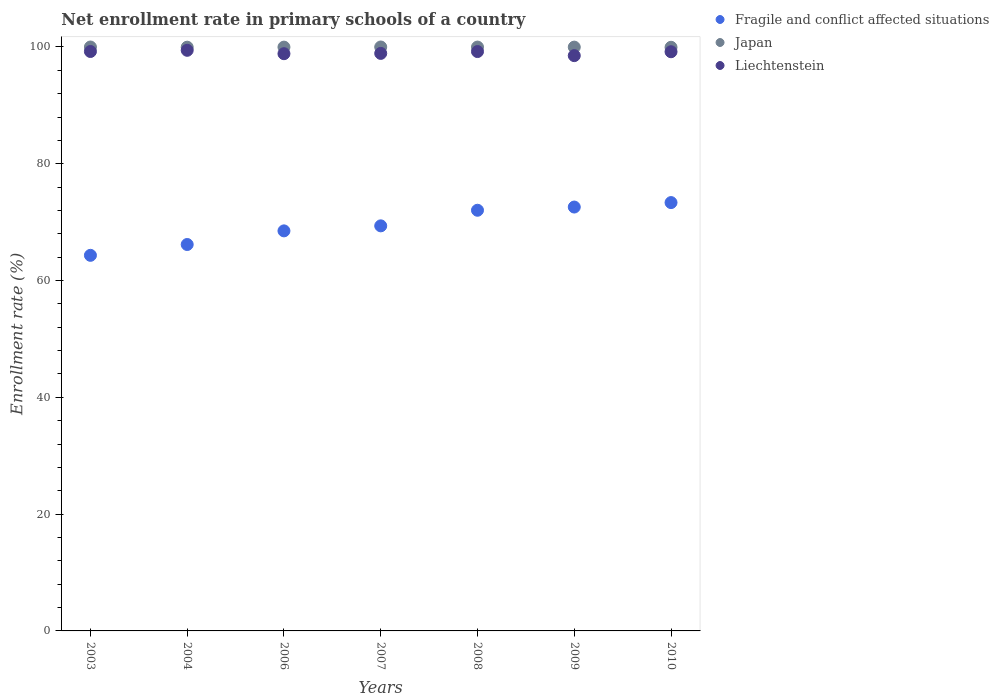How many different coloured dotlines are there?
Make the answer very short. 3. What is the enrollment rate in primary schools in Japan in 2006?
Make the answer very short. 99.98. Across all years, what is the maximum enrollment rate in primary schools in Fragile and conflict affected situations?
Make the answer very short. 73.35. Across all years, what is the minimum enrollment rate in primary schools in Japan?
Provide a short and direct response. 99.95. In which year was the enrollment rate in primary schools in Fragile and conflict affected situations maximum?
Keep it short and to the point. 2010. In which year was the enrollment rate in primary schools in Liechtenstein minimum?
Your response must be concise. 2009. What is the total enrollment rate in primary schools in Japan in the graph?
Make the answer very short. 699.85. What is the difference between the enrollment rate in primary schools in Liechtenstein in 2004 and that in 2006?
Provide a short and direct response. 0.58. What is the difference between the enrollment rate in primary schools in Fragile and conflict affected situations in 2007 and the enrollment rate in primary schools in Liechtenstein in 2008?
Your answer should be compact. -29.85. What is the average enrollment rate in primary schools in Japan per year?
Your answer should be very brief. 99.98. In the year 2003, what is the difference between the enrollment rate in primary schools in Fragile and conflict affected situations and enrollment rate in primary schools in Japan?
Offer a terse response. -35.67. What is the ratio of the enrollment rate in primary schools in Liechtenstein in 2008 to that in 2009?
Your answer should be compact. 1.01. Is the enrollment rate in primary schools in Liechtenstein in 2006 less than that in 2008?
Your answer should be compact. Yes. What is the difference between the highest and the second highest enrollment rate in primary schools in Japan?
Give a very brief answer. 0. What is the difference between the highest and the lowest enrollment rate in primary schools in Fragile and conflict affected situations?
Ensure brevity in your answer.  9.03. Is the sum of the enrollment rate in primary schools in Japan in 2008 and 2009 greater than the maximum enrollment rate in primary schools in Liechtenstein across all years?
Provide a short and direct response. Yes. Does the enrollment rate in primary schools in Liechtenstein monotonically increase over the years?
Provide a succinct answer. No. Is the enrollment rate in primary schools in Fragile and conflict affected situations strictly less than the enrollment rate in primary schools in Liechtenstein over the years?
Provide a succinct answer. Yes. How many years are there in the graph?
Give a very brief answer. 7. What is the difference between two consecutive major ticks on the Y-axis?
Your response must be concise. 20. Does the graph contain any zero values?
Give a very brief answer. No. Does the graph contain grids?
Your response must be concise. No. Where does the legend appear in the graph?
Your response must be concise. Top right. How many legend labels are there?
Make the answer very short. 3. How are the legend labels stacked?
Offer a terse response. Vertical. What is the title of the graph?
Make the answer very short. Net enrollment rate in primary schools of a country. What is the label or title of the Y-axis?
Offer a very short reply. Enrollment rate (%). What is the Enrollment rate (%) in Fragile and conflict affected situations in 2003?
Offer a terse response. 64.32. What is the Enrollment rate (%) in Japan in 2003?
Make the answer very short. 100. What is the Enrollment rate (%) in Liechtenstein in 2003?
Provide a short and direct response. 99.23. What is the Enrollment rate (%) of Fragile and conflict affected situations in 2004?
Your answer should be compact. 66.17. What is the Enrollment rate (%) in Japan in 2004?
Your answer should be compact. 99.97. What is the Enrollment rate (%) in Liechtenstein in 2004?
Your response must be concise. 99.43. What is the Enrollment rate (%) of Fragile and conflict affected situations in 2006?
Your answer should be very brief. 68.51. What is the Enrollment rate (%) in Japan in 2006?
Offer a terse response. 99.98. What is the Enrollment rate (%) in Liechtenstein in 2006?
Provide a succinct answer. 98.85. What is the Enrollment rate (%) of Fragile and conflict affected situations in 2007?
Give a very brief answer. 69.37. What is the Enrollment rate (%) of Japan in 2007?
Your response must be concise. 100. What is the Enrollment rate (%) of Liechtenstein in 2007?
Keep it short and to the point. 98.9. What is the Enrollment rate (%) in Fragile and conflict affected situations in 2008?
Keep it short and to the point. 72.04. What is the Enrollment rate (%) in Japan in 2008?
Offer a very short reply. 99.99. What is the Enrollment rate (%) in Liechtenstein in 2008?
Ensure brevity in your answer.  99.22. What is the Enrollment rate (%) of Fragile and conflict affected situations in 2009?
Make the answer very short. 72.59. What is the Enrollment rate (%) in Japan in 2009?
Your answer should be very brief. 99.98. What is the Enrollment rate (%) of Liechtenstein in 2009?
Make the answer very short. 98.52. What is the Enrollment rate (%) of Fragile and conflict affected situations in 2010?
Make the answer very short. 73.35. What is the Enrollment rate (%) of Japan in 2010?
Provide a short and direct response. 99.95. What is the Enrollment rate (%) of Liechtenstein in 2010?
Ensure brevity in your answer.  99.18. Across all years, what is the maximum Enrollment rate (%) in Fragile and conflict affected situations?
Keep it short and to the point. 73.35. Across all years, what is the maximum Enrollment rate (%) of Japan?
Your response must be concise. 100. Across all years, what is the maximum Enrollment rate (%) in Liechtenstein?
Offer a terse response. 99.43. Across all years, what is the minimum Enrollment rate (%) in Fragile and conflict affected situations?
Give a very brief answer. 64.32. Across all years, what is the minimum Enrollment rate (%) in Japan?
Make the answer very short. 99.95. Across all years, what is the minimum Enrollment rate (%) in Liechtenstein?
Keep it short and to the point. 98.52. What is the total Enrollment rate (%) of Fragile and conflict affected situations in the graph?
Offer a terse response. 486.36. What is the total Enrollment rate (%) of Japan in the graph?
Provide a short and direct response. 699.85. What is the total Enrollment rate (%) of Liechtenstein in the graph?
Your answer should be very brief. 693.34. What is the difference between the Enrollment rate (%) in Fragile and conflict affected situations in 2003 and that in 2004?
Provide a succinct answer. -1.85. What is the difference between the Enrollment rate (%) in Liechtenstein in 2003 and that in 2004?
Offer a terse response. -0.2. What is the difference between the Enrollment rate (%) in Fragile and conflict affected situations in 2003 and that in 2006?
Keep it short and to the point. -4.19. What is the difference between the Enrollment rate (%) of Japan in 2003 and that in 2006?
Your answer should be very brief. 0.02. What is the difference between the Enrollment rate (%) in Liechtenstein in 2003 and that in 2006?
Provide a succinct answer. 0.38. What is the difference between the Enrollment rate (%) in Fragile and conflict affected situations in 2003 and that in 2007?
Provide a succinct answer. -5.05. What is the difference between the Enrollment rate (%) of Japan in 2003 and that in 2007?
Provide a succinct answer. -0. What is the difference between the Enrollment rate (%) in Liechtenstein in 2003 and that in 2007?
Provide a short and direct response. 0.33. What is the difference between the Enrollment rate (%) of Fragile and conflict affected situations in 2003 and that in 2008?
Give a very brief answer. -7.72. What is the difference between the Enrollment rate (%) of Japan in 2003 and that in 2008?
Give a very brief answer. 0.01. What is the difference between the Enrollment rate (%) of Liechtenstein in 2003 and that in 2008?
Make the answer very short. 0.01. What is the difference between the Enrollment rate (%) in Fragile and conflict affected situations in 2003 and that in 2009?
Give a very brief answer. -8.27. What is the difference between the Enrollment rate (%) of Japan in 2003 and that in 2009?
Ensure brevity in your answer.  0.02. What is the difference between the Enrollment rate (%) in Liechtenstein in 2003 and that in 2009?
Make the answer very short. 0.71. What is the difference between the Enrollment rate (%) in Fragile and conflict affected situations in 2003 and that in 2010?
Provide a short and direct response. -9.03. What is the difference between the Enrollment rate (%) in Japan in 2003 and that in 2010?
Give a very brief answer. 0.05. What is the difference between the Enrollment rate (%) of Liechtenstein in 2003 and that in 2010?
Make the answer very short. 0.04. What is the difference between the Enrollment rate (%) of Fragile and conflict affected situations in 2004 and that in 2006?
Your answer should be very brief. -2.33. What is the difference between the Enrollment rate (%) in Japan in 2004 and that in 2006?
Your answer should be compact. -0.01. What is the difference between the Enrollment rate (%) of Liechtenstein in 2004 and that in 2006?
Offer a very short reply. 0.58. What is the difference between the Enrollment rate (%) of Fragile and conflict affected situations in 2004 and that in 2007?
Provide a short and direct response. -3.19. What is the difference between the Enrollment rate (%) in Japan in 2004 and that in 2007?
Keep it short and to the point. -0.03. What is the difference between the Enrollment rate (%) in Liechtenstein in 2004 and that in 2007?
Your response must be concise. 0.53. What is the difference between the Enrollment rate (%) of Fragile and conflict affected situations in 2004 and that in 2008?
Your response must be concise. -5.87. What is the difference between the Enrollment rate (%) of Japan in 2004 and that in 2008?
Give a very brief answer. -0.02. What is the difference between the Enrollment rate (%) of Liechtenstein in 2004 and that in 2008?
Provide a short and direct response. 0.21. What is the difference between the Enrollment rate (%) of Fragile and conflict affected situations in 2004 and that in 2009?
Give a very brief answer. -6.42. What is the difference between the Enrollment rate (%) of Japan in 2004 and that in 2009?
Your response must be concise. -0.01. What is the difference between the Enrollment rate (%) in Liechtenstein in 2004 and that in 2009?
Make the answer very short. 0.91. What is the difference between the Enrollment rate (%) of Fragile and conflict affected situations in 2004 and that in 2010?
Make the answer very short. -7.18. What is the difference between the Enrollment rate (%) of Japan in 2004 and that in 2010?
Keep it short and to the point. 0.02. What is the difference between the Enrollment rate (%) in Liechtenstein in 2004 and that in 2010?
Make the answer very short. 0.25. What is the difference between the Enrollment rate (%) in Fragile and conflict affected situations in 2006 and that in 2007?
Ensure brevity in your answer.  -0.86. What is the difference between the Enrollment rate (%) of Japan in 2006 and that in 2007?
Provide a succinct answer. -0.02. What is the difference between the Enrollment rate (%) in Liechtenstein in 2006 and that in 2007?
Ensure brevity in your answer.  -0.05. What is the difference between the Enrollment rate (%) in Fragile and conflict affected situations in 2006 and that in 2008?
Your response must be concise. -3.53. What is the difference between the Enrollment rate (%) in Japan in 2006 and that in 2008?
Provide a short and direct response. -0.01. What is the difference between the Enrollment rate (%) in Liechtenstein in 2006 and that in 2008?
Your answer should be very brief. -0.37. What is the difference between the Enrollment rate (%) of Fragile and conflict affected situations in 2006 and that in 2009?
Give a very brief answer. -4.08. What is the difference between the Enrollment rate (%) in Japan in 2006 and that in 2009?
Keep it short and to the point. -0. What is the difference between the Enrollment rate (%) of Liechtenstein in 2006 and that in 2009?
Provide a succinct answer. 0.33. What is the difference between the Enrollment rate (%) of Fragile and conflict affected situations in 2006 and that in 2010?
Your answer should be compact. -4.84. What is the difference between the Enrollment rate (%) of Japan in 2006 and that in 2010?
Offer a very short reply. 0.03. What is the difference between the Enrollment rate (%) in Liechtenstein in 2006 and that in 2010?
Make the answer very short. -0.33. What is the difference between the Enrollment rate (%) of Fragile and conflict affected situations in 2007 and that in 2008?
Your answer should be very brief. -2.67. What is the difference between the Enrollment rate (%) in Japan in 2007 and that in 2008?
Ensure brevity in your answer.  0.01. What is the difference between the Enrollment rate (%) of Liechtenstein in 2007 and that in 2008?
Keep it short and to the point. -0.32. What is the difference between the Enrollment rate (%) of Fragile and conflict affected situations in 2007 and that in 2009?
Make the answer very short. -3.22. What is the difference between the Enrollment rate (%) in Japan in 2007 and that in 2009?
Your answer should be very brief. 0.02. What is the difference between the Enrollment rate (%) in Liechtenstein in 2007 and that in 2009?
Ensure brevity in your answer.  0.38. What is the difference between the Enrollment rate (%) in Fragile and conflict affected situations in 2007 and that in 2010?
Provide a short and direct response. -3.98. What is the difference between the Enrollment rate (%) of Japan in 2007 and that in 2010?
Give a very brief answer. 0.05. What is the difference between the Enrollment rate (%) of Liechtenstein in 2007 and that in 2010?
Ensure brevity in your answer.  -0.28. What is the difference between the Enrollment rate (%) of Fragile and conflict affected situations in 2008 and that in 2009?
Your response must be concise. -0.55. What is the difference between the Enrollment rate (%) in Japan in 2008 and that in 2009?
Your response must be concise. 0.01. What is the difference between the Enrollment rate (%) in Liechtenstein in 2008 and that in 2009?
Give a very brief answer. 0.7. What is the difference between the Enrollment rate (%) in Fragile and conflict affected situations in 2008 and that in 2010?
Provide a short and direct response. -1.31. What is the difference between the Enrollment rate (%) in Japan in 2008 and that in 2010?
Keep it short and to the point. 0.04. What is the difference between the Enrollment rate (%) in Liechtenstein in 2008 and that in 2010?
Provide a succinct answer. 0.03. What is the difference between the Enrollment rate (%) of Fragile and conflict affected situations in 2009 and that in 2010?
Offer a terse response. -0.76. What is the difference between the Enrollment rate (%) in Japan in 2009 and that in 2010?
Your response must be concise. 0.03. What is the difference between the Enrollment rate (%) in Liechtenstein in 2009 and that in 2010?
Provide a short and direct response. -0.66. What is the difference between the Enrollment rate (%) of Fragile and conflict affected situations in 2003 and the Enrollment rate (%) of Japan in 2004?
Offer a very short reply. -35.64. What is the difference between the Enrollment rate (%) of Fragile and conflict affected situations in 2003 and the Enrollment rate (%) of Liechtenstein in 2004?
Your answer should be compact. -35.11. What is the difference between the Enrollment rate (%) in Japan in 2003 and the Enrollment rate (%) in Liechtenstein in 2004?
Give a very brief answer. 0.56. What is the difference between the Enrollment rate (%) in Fragile and conflict affected situations in 2003 and the Enrollment rate (%) in Japan in 2006?
Make the answer very short. -35.65. What is the difference between the Enrollment rate (%) in Fragile and conflict affected situations in 2003 and the Enrollment rate (%) in Liechtenstein in 2006?
Offer a very short reply. -34.53. What is the difference between the Enrollment rate (%) of Japan in 2003 and the Enrollment rate (%) of Liechtenstein in 2006?
Ensure brevity in your answer.  1.14. What is the difference between the Enrollment rate (%) of Fragile and conflict affected situations in 2003 and the Enrollment rate (%) of Japan in 2007?
Your answer should be compact. -35.68. What is the difference between the Enrollment rate (%) in Fragile and conflict affected situations in 2003 and the Enrollment rate (%) in Liechtenstein in 2007?
Offer a very short reply. -34.58. What is the difference between the Enrollment rate (%) of Japan in 2003 and the Enrollment rate (%) of Liechtenstein in 2007?
Keep it short and to the point. 1.09. What is the difference between the Enrollment rate (%) of Fragile and conflict affected situations in 2003 and the Enrollment rate (%) of Japan in 2008?
Keep it short and to the point. -35.66. What is the difference between the Enrollment rate (%) of Fragile and conflict affected situations in 2003 and the Enrollment rate (%) of Liechtenstein in 2008?
Your answer should be very brief. -34.9. What is the difference between the Enrollment rate (%) of Japan in 2003 and the Enrollment rate (%) of Liechtenstein in 2008?
Give a very brief answer. 0.78. What is the difference between the Enrollment rate (%) in Fragile and conflict affected situations in 2003 and the Enrollment rate (%) in Japan in 2009?
Ensure brevity in your answer.  -35.66. What is the difference between the Enrollment rate (%) in Fragile and conflict affected situations in 2003 and the Enrollment rate (%) in Liechtenstein in 2009?
Keep it short and to the point. -34.2. What is the difference between the Enrollment rate (%) in Japan in 2003 and the Enrollment rate (%) in Liechtenstein in 2009?
Give a very brief answer. 1.48. What is the difference between the Enrollment rate (%) in Fragile and conflict affected situations in 2003 and the Enrollment rate (%) in Japan in 2010?
Provide a succinct answer. -35.63. What is the difference between the Enrollment rate (%) in Fragile and conflict affected situations in 2003 and the Enrollment rate (%) in Liechtenstein in 2010?
Offer a terse response. -34.86. What is the difference between the Enrollment rate (%) of Japan in 2003 and the Enrollment rate (%) of Liechtenstein in 2010?
Offer a very short reply. 0.81. What is the difference between the Enrollment rate (%) of Fragile and conflict affected situations in 2004 and the Enrollment rate (%) of Japan in 2006?
Make the answer very short. -33.8. What is the difference between the Enrollment rate (%) of Fragile and conflict affected situations in 2004 and the Enrollment rate (%) of Liechtenstein in 2006?
Provide a short and direct response. -32.68. What is the difference between the Enrollment rate (%) of Japan in 2004 and the Enrollment rate (%) of Liechtenstein in 2006?
Provide a succinct answer. 1.11. What is the difference between the Enrollment rate (%) in Fragile and conflict affected situations in 2004 and the Enrollment rate (%) in Japan in 2007?
Give a very brief answer. -33.82. What is the difference between the Enrollment rate (%) in Fragile and conflict affected situations in 2004 and the Enrollment rate (%) in Liechtenstein in 2007?
Provide a short and direct response. -32.73. What is the difference between the Enrollment rate (%) in Japan in 2004 and the Enrollment rate (%) in Liechtenstein in 2007?
Your response must be concise. 1.06. What is the difference between the Enrollment rate (%) of Fragile and conflict affected situations in 2004 and the Enrollment rate (%) of Japan in 2008?
Your response must be concise. -33.81. What is the difference between the Enrollment rate (%) in Fragile and conflict affected situations in 2004 and the Enrollment rate (%) in Liechtenstein in 2008?
Give a very brief answer. -33.04. What is the difference between the Enrollment rate (%) of Japan in 2004 and the Enrollment rate (%) of Liechtenstein in 2008?
Keep it short and to the point. 0.75. What is the difference between the Enrollment rate (%) in Fragile and conflict affected situations in 2004 and the Enrollment rate (%) in Japan in 2009?
Your response must be concise. -33.8. What is the difference between the Enrollment rate (%) of Fragile and conflict affected situations in 2004 and the Enrollment rate (%) of Liechtenstein in 2009?
Keep it short and to the point. -32.35. What is the difference between the Enrollment rate (%) in Japan in 2004 and the Enrollment rate (%) in Liechtenstein in 2009?
Provide a short and direct response. 1.45. What is the difference between the Enrollment rate (%) of Fragile and conflict affected situations in 2004 and the Enrollment rate (%) of Japan in 2010?
Provide a succinct answer. -33.78. What is the difference between the Enrollment rate (%) of Fragile and conflict affected situations in 2004 and the Enrollment rate (%) of Liechtenstein in 2010?
Keep it short and to the point. -33.01. What is the difference between the Enrollment rate (%) of Japan in 2004 and the Enrollment rate (%) of Liechtenstein in 2010?
Your answer should be very brief. 0.78. What is the difference between the Enrollment rate (%) in Fragile and conflict affected situations in 2006 and the Enrollment rate (%) in Japan in 2007?
Offer a very short reply. -31.49. What is the difference between the Enrollment rate (%) in Fragile and conflict affected situations in 2006 and the Enrollment rate (%) in Liechtenstein in 2007?
Provide a succinct answer. -30.39. What is the difference between the Enrollment rate (%) of Japan in 2006 and the Enrollment rate (%) of Liechtenstein in 2007?
Provide a succinct answer. 1.07. What is the difference between the Enrollment rate (%) in Fragile and conflict affected situations in 2006 and the Enrollment rate (%) in Japan in 2008?
Your answer should be compact. -31.48. What is the difference between the Enrollment rate (%) of Fragile and conflict affected situations in 2006 and the Enrollment rate (%) of Liechtenstein in 2008?
Give a very brief answer. -30.71. What is the difference between the Enrollment rate (%) in Japan in 2006 and the Enrollment rate (%) in Liechtenstein in 2008?
Make the answer very short. 0.76. What is the difference between the Enrollment rate (%) of Fragile and conflict affected situations in 2006 and the Enrollment rate (%) of Japan in 2009?
Your answer should be very brief. -31.47. What is the difference between the Enrollment rate (%) of Fragile and conflict affected situations in 2006 and the Enrollment rate (%) of Liechtenstein in 2009?
Your answer should be compact. -30.01. What is the difference between the Enrollment rate (%) in Japan in 2006 and the Enrollment rate (%) in Liechtenstein in 2009?
Your answer should be very brief. 1.46. What is the difference between the Enrollment rate (%) in Fragile and conflict affected situations in 2006 and the Enrollment rate (%) in Japan in 2010?
Provide a succinct answer. -31.44. What is the difference between the Enrollment rate (%) of Fragile and conflict affected situations in 2006 and the Enrollment rate (%) of Liechtenstein in 2010?
Provide a short and direct response. -30.68. What is the difference between the Enrollment rate (%) in Japan in 2006 and the Enrollment rate (%) in Liechtenstein in 2010?
Ensure brevity in your answer.  0.79. What is the difference between the Enrollment rate (%) of Fragile and conflict affected situations in 2007 and the Enrollment rate (%) of Japan in 2008?
Your answer should be very brief. -30.62. What is the difference between the Enrollment rate (%) in Fragile and conflict affected situations in 2007 and the Enrollment rate (%) in Liechtenstein in 2008?
Ensure brevity in your answer.  -29.85. What is the difference between the Enrollment rate (%) in Japan in 2007 and the Enrollment rate (%) in Liechtenstein in 2008?
Ensure brevity in your answer.  0.78. What is the difference between the Enrollment rate (%) of Fragile and conflict affected situations in 2007 and the Enrollment rate (%) of Japan in 2009?
Your response must be concise. -30.61. What is the difference between the Enrollment rate (%) in Fragile and conflict affected situations in 2007 and the Enrollment rate (%) in Liechtenstein in 2009?
Give a very brief answer. -29.15. What is the difference between the Enrollment rate (%) of Japan in 2007 and the Enrollment rate (%) of Liechtenstein in 2009?
Make the answer very short. 1.48. What is the difference between the Enrollment rate (%) in Fragile and conflict affected situations in 2007 and the Enrollment rate (%) in Japan in 2010?
Make the answer very short. -30.58. What is the difference between the Enrollment rate (%) of Fragile and conflict affected situations in 2007 and the Enrollment rate (%) of Liechtenstein in 2010?
Provide a short and direct response. -29.82. What is the difference between the Enrollment rate (%) of Japan in 2007 and the Enrollment rate (%) of Liechtenstein in 2010?
Offer a very short reply. 0.81. What is the difference between the Enrollment rate (%) of Fragile and conflict affected situations in 2008 and the Enrollment rate (%) of Japan in 2009?
Give a very brief answer. -27.94. What is the difference between the Enrollment rate (%) in Fragile and conflict affected situations in 2008 and the Enrollment rate (%) in Liechtenstein in 2009?
Give a very brief answer. -26.48. What is the difference between the Enrollment rate (%) in Japan in 2008 and the Enrollment rate (%) in Liechtenstein in 2009?
Ensure brevity in your answer.  1.46. What is the difference between the Enrollment rate (%) in Fragile and conflict affected situations in 2008 and the Enrollment rate (%) in Japan in 2010?
Ensure brevity in your answer.  -27.91. What is the difference between the Enrollment rate (%) in Fragile and conflict affected situations in 2008 and the Enrollment rate (%) in Liechtenstein in 2010?
Offer a very short reply. -27.14. What is the difference between the Enrollment rate (%) of Japan in 2008 and the Enrollment rate (%) of Liechtenstein in 2010?
Ensure brevity in your answer.  0.8. What is the difference between the Enrollment rate (%) of Fragile and conflict affected situations in 2009 and the Enrollment rate (%) of Japan in 2010?
Make the answer very short. -27.36. What is the difference between the Enrollment rate (%) of Fragile and conflict affected situations in 2009 and the Enrollment rate (%) of Liechtenstein in 2010?
Make the answer very short. -26.6. What is the difference between the Enrollment rate (%) of Japan in 2009 and the Enrollment rate (%) of Liechtenstein in 2010?
Keep it short and to the point. 0.79. What is the average Enrollment rate (%) of Fragile and conflict affected situations per year?
Provide a succinct answer. 69.48. What is the average Enrollment rate (%) in Japan per year?
Provide a succinct answer. 99.98. What is the average Enrollment rate (%) in Liechtenstein per year?
Your answer should be compact. 99.05. In the year 2003, what is the difference between the Enrollment rate (%) in Fragile and conflict affected situations and Enrollment rate (%) in Japan?
Give a very brief answer. -35.67. In the year 2003, what is the difference between the Enrollment rate (%) in Fragile and conflict affected situations and Enrollment rate (%) in Liechtenstein?
Offer a terse response. -34.91. In the year 2003, what is the difference between the Enrollment rate (%) of Japan and Enrollment rate (%) of Liechtenstein?
Your answer should be very brief. 0.77. In the year 2004, what is the difference between the Enrollment rate (%) in Fragile and conflict affected situations and Enrollment rate (%) in Japan?
Your response must be concise. -33.79. In the year 2004, what is the difference between the Enrollment rate (%) of Fragile and conflict affected situations and Enrollment rate (%) of Liechtenstein?
Make the answer very short. -33.26. In the year 2004, what is the difference between the Enrollment rate (%) in Japan and Enrollment rate (%) in Liechtenstein?
Provide a short and direct response. 0.53. In the year 2006, what is the difference between the Enrollment rate (%) in Fragile and conflict affected situations and Enrollment rate (%) in Japan?
Your answer should be very brief. -31.47. In the year 2006, what is the difference between the Enrollment rate (%) of Fragile and conflict affected situations and Enrollment rate (%) of Liechtenstein?
Offer a very short reply. -30.34. In the year 2006, what is the difference between the Enrollment rate (%) in Japan and Enrollment rate (%) in Liechtenstein?
Provide a short and direct response. 1.12. In the year 2007, what is the difference between the Enrollment rate (%) of Fragile and conflict affected situations and Enrollment rate (%) of Japan?
Provide a succinct answer. -30.63. In the year 2007, what is the difference between the Enrollment rate (%) of Fragile and conflict affected situations and Enrollment rate (%) of Liechtenstein?
Your answer should be very brief. -29.53. In the year 2007, what is the difference between the Enrollment rate (%) in Japan and Enrollment rate (%) in Liechtenstein?
Provide a succinct answer. 1.1. In the year 2008, what is the difference between the Enrollment rate (%) in Fragile and conflict affected situations and Enrollment rate (%) in Japan?
Offer a terse response. -27.94. In the year 2008, what is the difference between the Enrollment rate (%) of Fragile and conflict affected situations and Enrollment rate (%) of Liechtenstein?
Your answer should be very brief. -27.18. In the year 2008, what is the difference between the Enrollment rate (%) of Japan and Enrollment rate (%) of Liechtenstein?
Give a very brief answer. 0.77. In the year 2009, what is the difference between the Enrollment rate (%) of Fragile and conflict affected situations and Enrollment rate (%) of Japan?
Your response must be concise. -27.39. In the year 2009, what is the difference between the Enrollment rate (%) of Fragile and conflict affected situations and Enrollment rate (%) of Liechtenstein?
Ensure brevity in your answer.  -25.93. In the year 2009, what is the difference between the Enrollment rate (%) of Japan and Enrollment rate (%) of Liechtenstein?
Offer a terse response. 1.46. In the year 2010, what is the difference between the Enrollment rate (%) of Fragile and conflict affected situations and Enrollment rate (%) of Japan?
Provide a succinct answer. -26.6. In the year 2010, what is the difference between the Enrollment rate (%) in Fragile and conflict affected situations and Enrollment rate (%) in Liechtenstein?
Your answer should be very brief. -25.83. In the year 2010, what is the difference between the Enrollment rate (%) in Japan and Enrollment rate (%) in Liechtenstein?
Provide a succinct answer. 0.77. What is the ratio of the Enrollment rate (%) of Japan in 2003 to that in 2004?
Keep it short and to the point. 1. What is the ratio of the Enrollment rate (%) of Fragile and conflict affected situations in 2003 to that in 2006?
Provide a short and direct response. 0.94. What is the ratio of the Enrollment rate (%) of Japan in 2003 to that in 2006?
Ensure brevity in your answer.  1. What is the ratio of the Enrollment rate (%) in Fragile and conflict affected situations in 2003 to that in 2007?
Your answer should be compact. 0.93. What is the ratio of the Enrollment rate (%) in Japan in 2003 to that in 2007?
Offer a very short reply. 1. What is the ratio of the Enrollment rate (%) in Fragile and conflict affected situations in 2003 to that in 2008?
Make the answer very short. 0.89. What is the ratio of the Enrollment rate (%) of Japan in 2003 to that in 2008?
Offer a terse response. 1. What is the ratio of the Enrollment rate (%) of Liechtenstein in 2003 to that in 2008?
Give a very brief answer. 1. What is the ratio of the Enrollment rate (%) in Fragile and conflict affected situations in 2003 to that in 2009?
Your response must be concise. 0.89. What is the ratio of the Enrollment rate (%) in Fragile and conflict affected situations in 2003 to that in 2010?
Keep it short and to the point. 0.88. What is the ratio of the Enrollment rate (%) in Japan in 2003 to that in 2010?
Your answer should be very brief. 1. What is the ratio of the Enrollment rate (%) of Liechtenstein in 2003 to that in 2010?
Your answer should be compact. 1. What is the ratio of the Enrollment rate (%) of Fragile and conflict affected situations in 2004 to that in 2006?
Your response must be concise. 0.97. What is the ratio of the Enrollment rate (%) of Japan in 2004 to that in 2006?
Give a very brief answer. 1. What is the ratio of the Enrollment rate (%) of Liechtenstein in 2004 to that in 2006?
Your answer should be compact. 1.01. What is the ratio of the Enrollment rate (%) in Fragile and conflict affected situations in 2004 to that in 2007?
Offer a very short reply. 0.95. What is the ratio of the Enrollment rate (%) of Japan in 2004 to that in 2007?
Give a very brief answer. 1. What is the ratio of the Enrollment rate (%) in Liechtenstein in 2004 to that in 2007?
Make the answer very short. 1.01. What is the ratio of the Enrollment rate (%) of Fragile and conflict affected situations in 2004 to that in 2008?
Give a very brief answer. 0.92. What is the ratio of the Enrollment rate (%) in Japan in 2004 to that in 2008?
Ensure brevity in your answer.  1. What is the ratio of the Enrollment rate (%) of Liechtenstein in 2004 to that in 2008?
Provide a short and direct response. 1. What is the ratio of the Enrollment rate (%) of Fragile and conflict affected situations in 2004 to that in 2009?
Make the answer very short. 0.91. What is the ratio of the Enrollment rate (%) of Japan in 2004 to that in 2009?
Provide a succinct answer. 1. What is the ratio of the Enrollment rate (%) of Liechtenstein in 2004 to that in 2009?
Make the answer very short. 1.01. What is the ratio of the Enrollment rate (%) in Fragile and conflict affected situations in 2004 to that in 2010?
Provide a short and direct response. 0.9. What is the ratio of the Enrollment rate (%) in Liechtenstein in 2004 to that in 2010?
Your response must be concise. 1. What is the ratio of the Enrollment rate (%) in Fragile and conflict affected situations in 2006 to that in 2007?
Give a very brief answer. 0.99. What is the ratio of the Enrollment rate (%) of Liechtenstein in 2006 to that in 2007?
Offer a very short reply. 1. What is the ratio of the Enrollment rate (%) of Fragile and conflict affected situations in 2006 to that in 2008?
Your answer should be very brief. 0.95. What is the ratio of the Enrollment rate (%) of Japan in 2006 to that in 2008?
Your answer should be very brief. 1. What is the ratio of the Enrollment rate (%) of Liechtenstein in 2006 to that in 2008?
Give a very brief answer. 1. What is the ratio of the Enrollment rate (%) of Fragile and conflict affected situations in 2006 to that in 2009?
Offer a terse response. 0.94. What is the ratio of the Enrollment rate (%) in Liechtenstein in 2006 to that in 2009?
Give a very brief answer. 1. What is the ratio of the Enrollment rate (%) in Fragile and conflict affected situations in 2006 to that in 2010?
Ensure brevity in your answer.  0.93. What is the ratio of the Enrollment rate (%) in Fragile and conflict affected situations in 2007 to that in 2008?
Keep it short and to the point. 0.96. What is the ratio of the Enrollment rate (%) of Fragile and conflict affected situations in 2007 to that in 2009?
Offer a very short reply. 0.96. What is the ratio of the Enrollment rate (%) of Japan in 2007 to that in 2009?
Provide a short and direct response. 1. What is the ratio of the Enrollment rate (%) in Fragile and conflict affected situations in 2007 to that in 2010?
Provide a short and direct response. 0.95. What is the ratio of the Enrollment rate (%) in Japan in 2007 to that in 2010?
Provide a short and direct response. 1. What is the ratio of the Enrollment rate (%) of Fragile and conflict affected situations in 2008 to that in 2009?
Make the answer very short. 0.99. What is the ratio of the Enrollment rate (%) in Japan in 2008 to that in 2009?
Offer a terse response. 1. What is the ratio of the Enrollment rate (%) in Liechtenstein in 2008 to that in 2009?
Provide a short and direct response. 1.01. What is the ratio of the Enrollment rate (%) of Fragile and conflict affected situations in 2008 to that in 2010?
Keep it short and to the point. 0.98. What is the ratio of the Enrollment rate (%) of Japan in 2008 to that in 2010?
Your answer should be very brief. 1. What is the ratio of the Enrollment rate (%) of Liechtenstein in 2008 to that in 2010?
Provide a short and direct response. 1. What is the ratio of the Enrollment rate (%) of Fragile and conflict affected situations in 2009 to that in 2010?
Provide a short and direct response. 0.99. What is the difference between the highest and the second highest Enrollment rate (%) of Fragile and conflict affected situations?
Your answer should be compact. 0.76. What is the difference between the highest and the second highest Enrollment rate (%) in Japan?
Make the answer very short. 0. What is the difference between the highest and the second highest Enrollment rate (%) of Liechtenstein?
Offer a terse response. 0.2. What is the difference between the highest and the lowest Enrollment rate (%) of Fragile and conflict affected situations?
Keep it short and to the point. 9.03. What is the difference between the highest and the lowest Enrollment rate (%) of Japan?
Offer a terse response. 0.05. What is the difference between the highest and the lowest Enrollment rate (%) of Liechtenstein?
Keep it short and to the point. 0.91. 